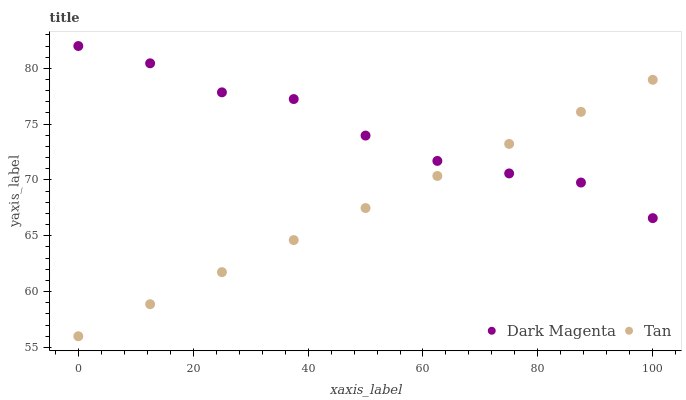Does Tan have the minimum area under the curve?
Answer yes or no. Yes. Does Dark Magenta have the maximum area under the curve?
Answer yes or no. Yes. Does Dark Magenta have the minimum area under the curve?
Answer yes or no. No. Is Tan the smoothest?
Answer yes or no. Yes. Is Dark Magenta the roughest?
Answer yes or no. Yes. Is Dark Magenta the smoothest?
Answer yes or no. No. Does Tan have the lowest value?
Answer yes or no. Yes. Does Dark Magenta have the lowest value?
Answer yes or no. No. Does Dark Magenta have the highest value?
Answer yes or no. Yes. Does Dark Magenta intersect Tan?
Answer yes or no. Yes. Is Dark Magenta less than Tan?
Answer yes or no. No. Is Dark Magenta greater than Tan?
Answer yes or no. No. 